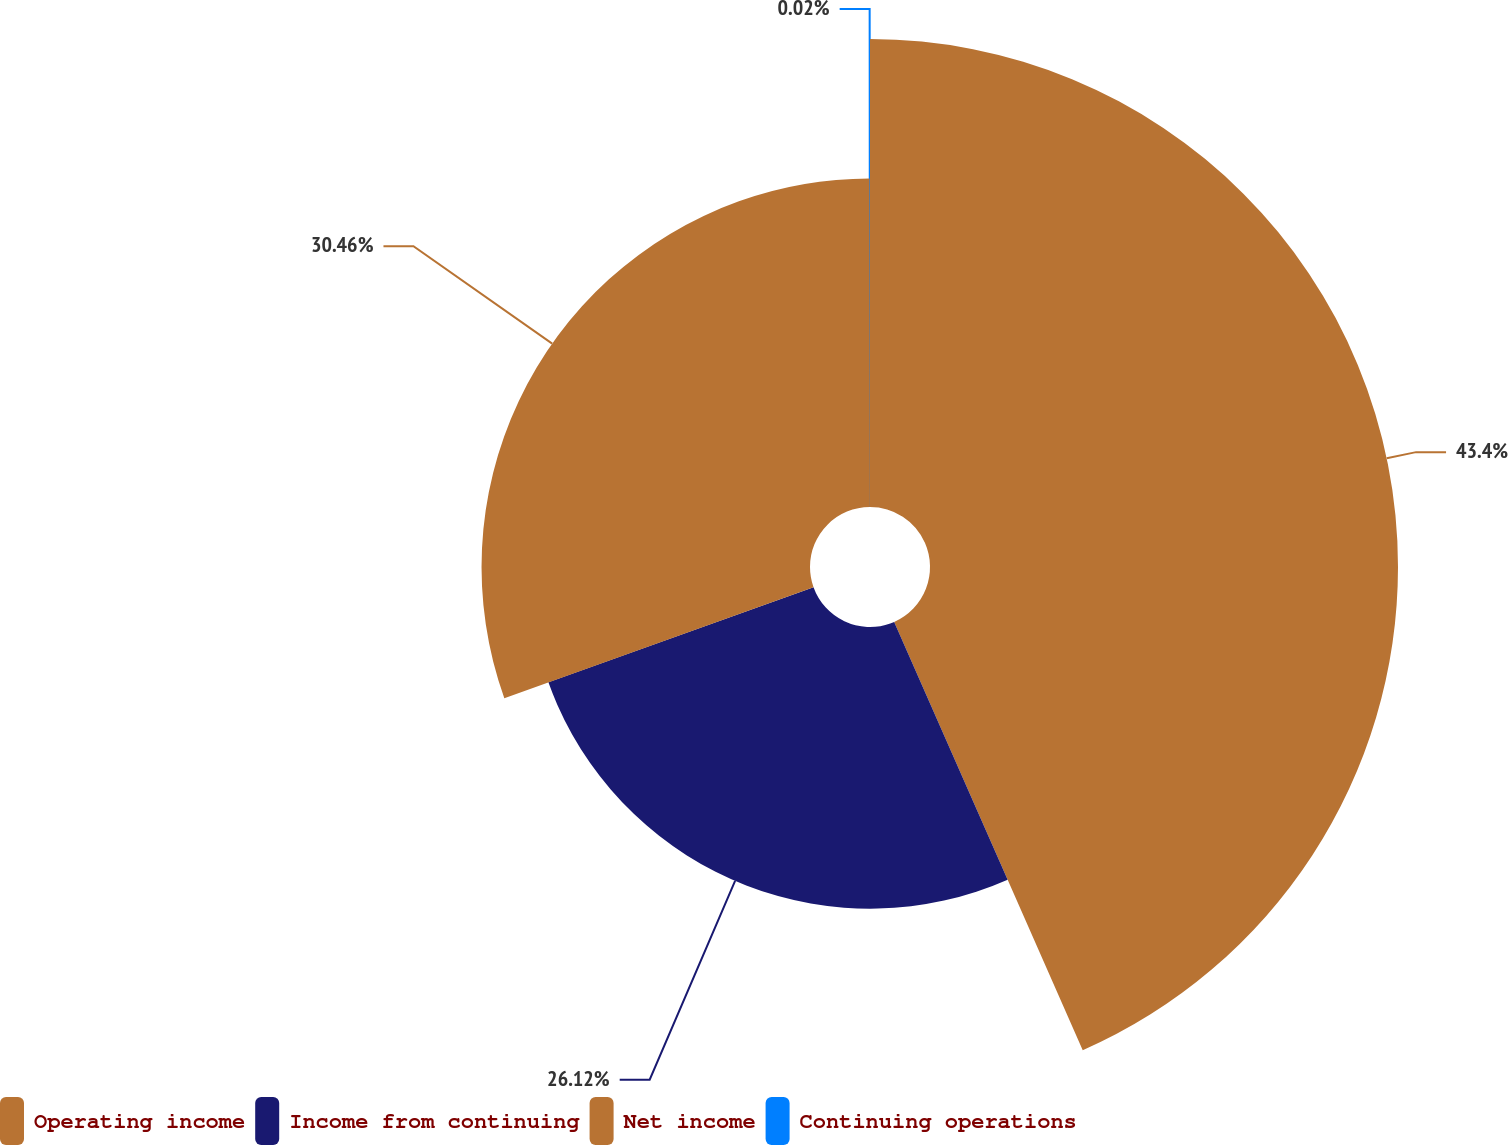Convert chart. <chart><loc_0><loc_0><loc_500><loc_500><pie_chart><fcel>Operating income<fcel>Income from continuing<fcel>Net income<fcel>Continuing operations<nl><fcel>43.4%<fcel>26.12%<fcel>30.46%<fcel>0.02%<nl></chart> 